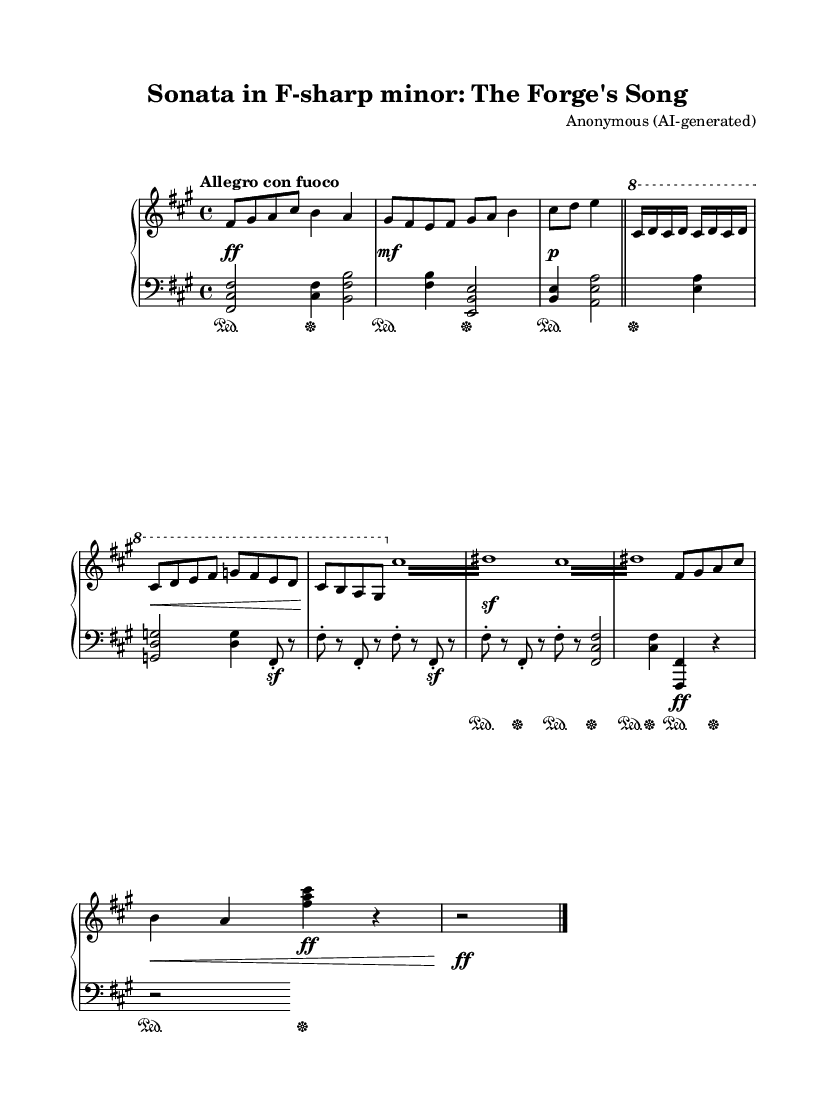What is the key signature of this music? The key signature shows F-sharp minor, indicated by three sharps (F#, C#, and G#) in the key signature at the beginning of the staff.
Answer: F-sharp minor What is the time signature of this music? The time signature is 4/4, shown at the beginning of the sheet music. This indicates that there are four beats in each measure and the quarter note gets one beat.
Answer: 4/4 What is the tempo marking for this piece? The tempo marking "Allegro con fuoco" suggests a fast pace with passion, typically around 120-168 beats per minute. This marking appears above the staff at the start of the music.
Answer: Allegro con fuoco How many measures are present in the music? Counting the groupings separated by bar lines, there are a total of 10 measures in this piece.
Answer: 10 What is a distinctive feature of the melody that represents metalworking? The repeated tremolos and anvil strikes in the score symbolize the sounds of metalworking, characterized by swift, rhythmic patterns resembling hammer strikes. These elements are evident in both the right-hand and left-hand parts.
Answer: Tremolo and anvil strikes How does the music depict the dynamic changes throughout the piece? The piece includes various dynamic markings such as ff (forte), mf (mezzo forte), and p (piano), which indicate shifts from loud to soft, allowing for expressive interpretation. These changes are strategically placed in the score to enhance the emotive quality of the music.
Answer: Varied dynamics 